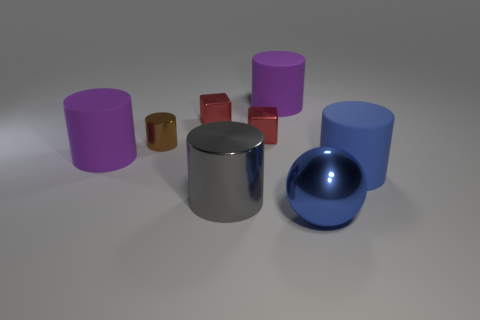Subtract all large shiny cylinders. How many cylinders are left? 4 Subtract all blue spheres. How many purple cylinders are left? 2 Subtract 1 cubes. How many cubes are left? 1 Add 1 tiny brown metal cylinders. How many objects exist? 9 Subtract all gray cylinders. How many cylinders are left? 4 Subtract 0 green balls. How many objects are left? 8 Subtract all spheres. How many objects are left? 7 Subtract all cyan balls. Subtract all gray cylinders. How many balls are left? 1 Subtract all big objects. Subtract all small gray spheres. How many objects are left? 3 Add 8 big purple cylinders. How many big purple cylinders are left? 10 